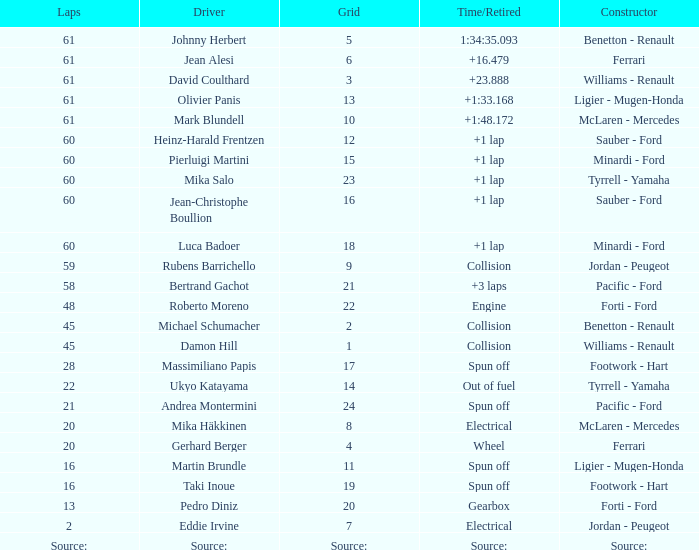How many laps does roberto moreno have? 48.0. 